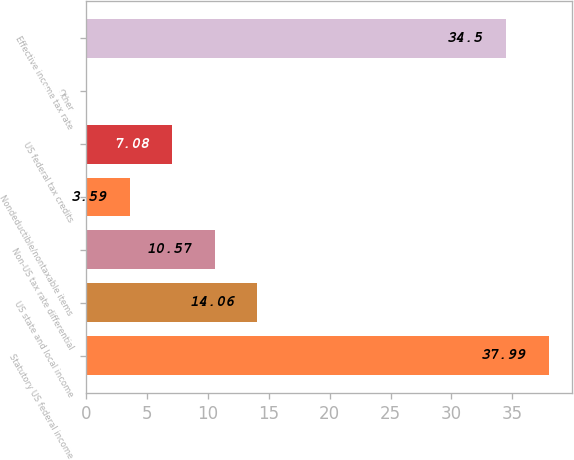Convert chart to OTSL. <chart><loc_0><loc_0><loc_500><loc_500><bar_chart><fcel>Statutory US federal income<fcel>US state and local income<fcel>Non-US tax rate differential<fcel>Nondeductible/nontaxable items<fcel>US federal tax credits<fcel>Other<fcel>Effective income tax rate<nl><fcel>37.99<fcel>14.06<fcel>10.57<fcel>3.59<fcel>7.08<fcel>0.1<fcel>34.5<nl></chart> 